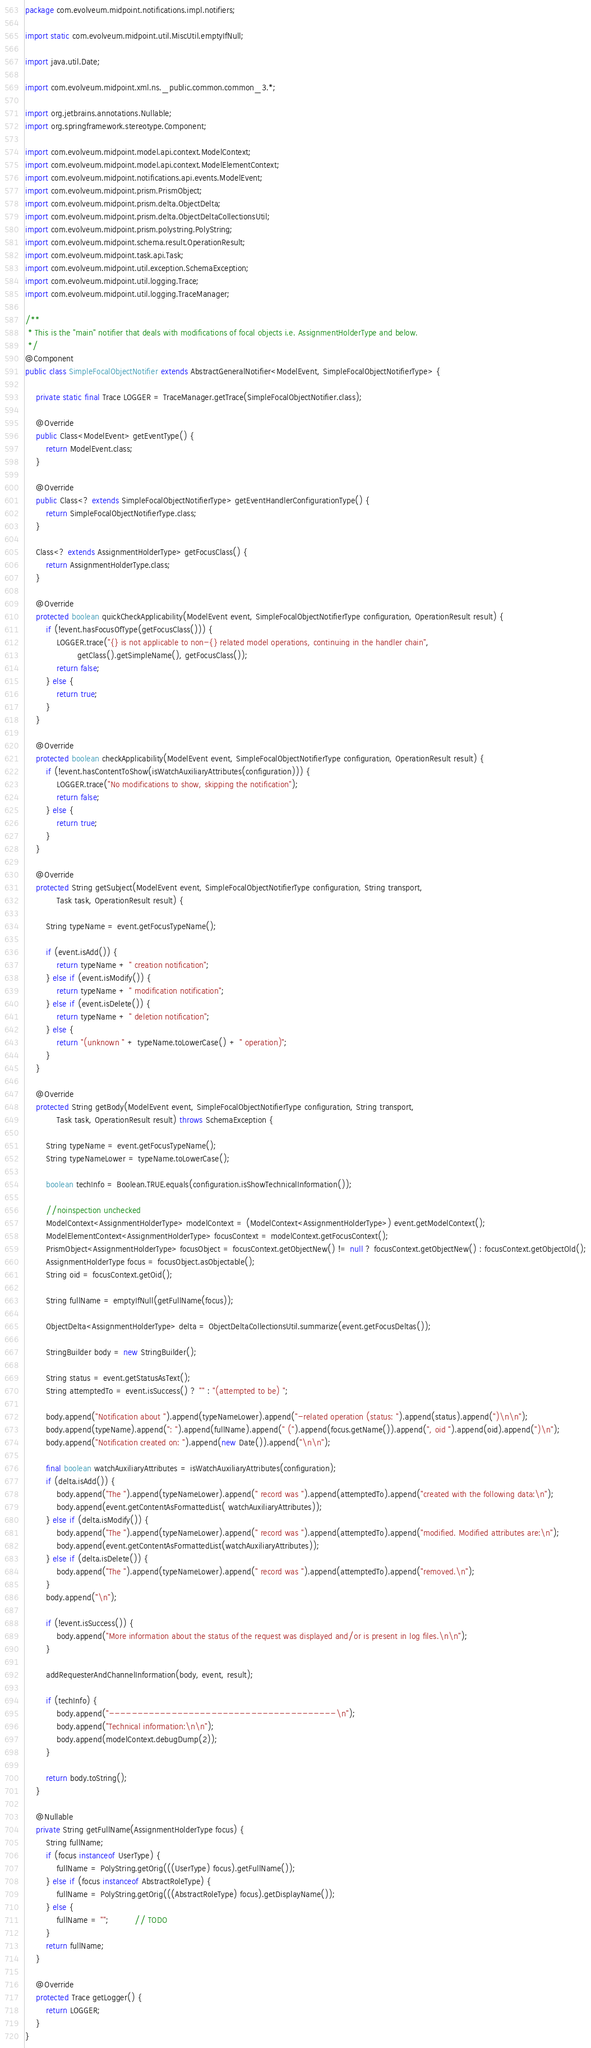<code> <loc_0><loc_0><loc_500><loc_500><_Java_>package com.evolveum.midpoint.notifications.impl.notifiers;

import static com.evolveum.midpoint.util.MiscUtil.emptyIfNull;

import java.util.Date;

import com.evolveum.midpoint.xml.ns._public.common.common_3.*;

import org.jetbrains.annotations.Nullable;
import org.springframework.stereotype.Component;

import com.evolveum.midpoint.model.api.context.ModelContext;
import com.evolveum.midpoint.model.api.context.ModelElementContext;
import com.evolveum.midpoint.notifications.api.events.ModelEvent;
import com.evolveum.midpoint.prism.PrismObject;
import com.evolveum.midpoint.prism.delta.ObjectDelta;
import com.evolveum.midpoint.prism.delta.ObjectDeltaCollectionsUtil;
import com.evolveum.midpoint.prism.polystring.PolyString;
import com.evolveum.midpoint.schema.result.OperationResult;
import com.evolveum.midpoint.task.api.Task;
import com.evolveum.midpoint.util.exception.SchemaException;
import com.evolveum.midpoint.util.logging.Trace;
import com.evolveum.midpoint.util.logging.TraceManager;

/**
 * This is the "main" notifier that deals with modifications of focal objects i.e. AssignmentHolderType and below.
 */
@Component
public class SimpleFocalObjectNotifier extends AbstractGeneralNotifier<ModelEvent, SimpleFocalObjectNotifierType> {

    private static final Trace LOGGER = TraceManager.getTrace(SimpleFocalObjectNotifier.class);

    @Override
    public Class<ModelEvent> getEventType() {
        return ModelEvent.class;
    }

    @Override
    public Class<? extends SimpleFocalObjectNotifierType> getEventHandlerConfigurationType() {
        return SimpleFocalObjectNotifierType.class;
    }

    Class<? extends AssignmentHolderType> getFocusClass() {
        return AssignmentHolderType.class;
    }

    @Override
    protected boolean quickCheckApplicability(ModelEvent event, SimpleFocalObjectNotifierType configuration, OperationResult result) {
        if (!event.hasFocusOfType(getFocusClass())) {
            LOGGER.trace("{} is not applicable to non-{} related model operations, continuing in the handler chain",
                    getClass().getSimpleName(), getFocusClass());
            return false;
        } else {
            return true;
        }
    }

    @Override
    protected boolean checkApplicability(ModelEvent event, SimpleFocalObjectNotifierType configuration, OperationResult result) {
        if (!event.hasContentToShow(isWatchAuxiliaryAttributes(configuration))) {
            LOGGER.trace("No modifications to show, skipping the notification");
            return false;
        } else {
            return true;
        }
    }

    @Override
    protected String getSubject(ModelEvent event, SimpleFocalObjectNotifierType configuration, String transport,
            Task task, OperationResult result) {

        String typeName = event.getFocusTypeName();

        if (event.isAdd()) {
            return typeName + " creation notification";
        } else if (event.isModify()) {
            return typeName + " modification notification";
        } else if (event.isDelete()) {
            return typeName + " deletion notification";
        } else {
            return "(unknown " + typeName.toLowerCase() + " operation)";
        }
    }

    @Override
    protected String getBody(ModelEvent event, SimpleFocalObjectNotifierType configuration, String transport,
            Task task, OperationResult result) throws SchemaException {

        String typeName = event.getFocusTypeName();
        String typeNameLower = typeName.toLowerCase();

        boolean techInfo = Boolean.TRUE.equals(configuration.isShowTechnicalInformation());

        //noinspection unchecked
        ModelContext<AssignmentHolderType> modelContext = (ModelContext<AssignmentHolderType>) event.getModelContext();
        ModelElementContext<AssignmentHolderType> focusContext = modelContext.getFocusContext();
        PrismObject<AssignmentHolderType> focusObject = focusContext.getObjectNew() != null ? focusContext.getObjectNew() : focusContext.getObjectOld();
        AssignmentHolderType focus = focusObject.asObjectable();
        String oid = focusContext.getOid();

        String fullName = emptyIfNull(getFullName(focus));

        ObjectDelta<AssignmentHolderType> delta = ObjectDeltaCollectionsUtil.summarize(event.getFocusDeltas());

        StringBuilder body = new StringBuilder();

        String status = event.getStatusAsText();
        String attemptedTo = event.isSuccess() ? "" : "(attempted to be) ";

        body.append("Notification about ").append(typeNameLower).append("-related operation (status: ").append(status).append(")\n\n");
        body.append(typeName).append(": ").append(fullName).append(" (").append(focus.getName()).append(", oid ").append(oid).append(")\n");
        body.append("Notification created on: ").append(new Date()).append("\n\n");

        final boolean watchAuxiliaryAttributes = isWatchAuxiliaryAttributes(configuration);
        if (delta.isAdd()) {
            body.append("The ").append(typeNameLower).append(" record was ").append(attemptedTo).append("created with the following data:\n");
            body.append(event.getContentAsFormattedList( watchAuxiliaryAttributes));
        } else if (delta.isModify()) {
            body.append("The ").append(typeNameLower).append(" record was ").append(attemptedTo).append("modified. Modified attributes are:\n");
            body.append(event.getContentAsFormattedList(watchAuxiliaryAttributes));
        } else if (delta.isDelete()) {
            body.append("The ").append(typeNameLower).append(" record was ").append(attemptedTo).append("removed.\n");
        }
        body.append("\n");

        if (!event.isSuccess()) {
            body.append("More information about the status of the request was displayed and/or is present in log files.\n\n");
        }

        addRequesterAndChannelInformation(body, event, result);

        if (techInfo) {
            body.append("----------------------------------------\n");
            body.append("Technical information:\n\n");
            body.append(modelContext.debugDump(2));
        }

        return body.toString();
    }

    @Nullable
    private String getFullName(AssignmentHolderType focus) {
        String fullName;
        if (focus instanceof UserType) {
            fullName = PolyString.getOrig(((UserType) focus).getFullName());
        } else if (focus instanceof AbstractRoleType) {
            fullName = PolyString.getOrig(((AbstractRoleType) focus).getDisplayName());
        } else {
            fullName = "";          // TODO
        }
        return fullName;
    }

    @Override
    protected Trace getLogger() {
        return LOGGER;
    }
}
</code> 